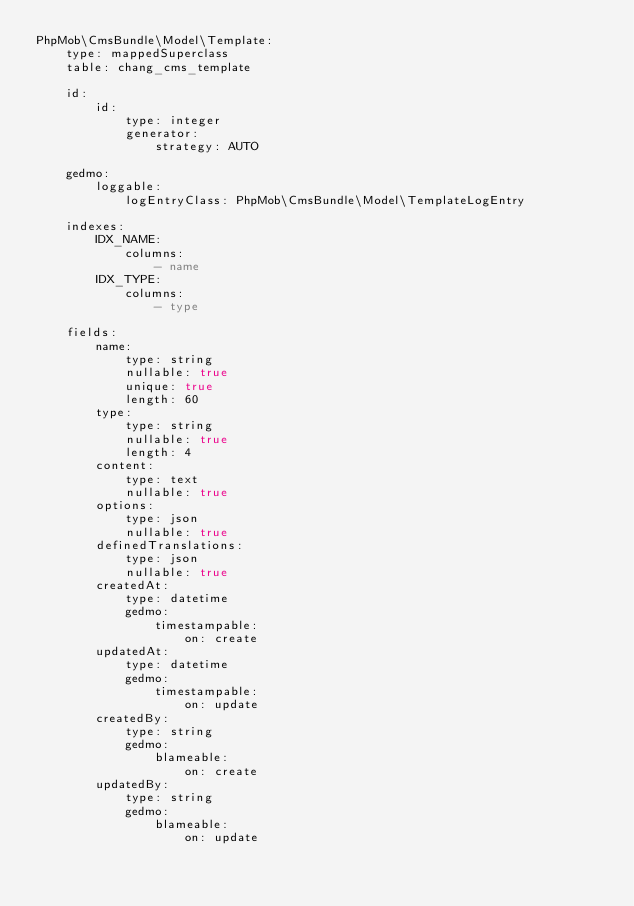<code> <loc_0><loc_0><loc_500><loc_500><_YAML_>PhpMob\CmsBundle\Model\Template:
    type: mappedSuperclass
    table: chang_cms_template

    id:
        id:
            type: integer
            generator:
                strategy: AUTO

    gedmo:
        loggable:
            logEntryClass: PhpMob\CmsBundle\Model\TemplateLogEntry

    indexes:
        IDX_NAME:
            columns:
                - name
        IDX_TYPE:
            columns:
                - type

    fields:
        name:
            type: string
            nullable: true
            unique: true
            length: 60
        type:
            type: string
            nullable: true
            length: 4
        content:
            type: text
            nullable: true
        options:
            type: json
            nullable: true
        definedTranslations:
            type: json
            nullable: true
        createdAt:
            type: datetime
            gedmo:
                timestampable:
                    on: create
        updatedAt:
            type: datetime
            gedmo:
                timestampable:
                    on: update
        createdBy:
            type: string
            gedmo:
                blameable:
                    on: create
        updatedBy:
            type: string
            gedmo:
                blameable:
                    on: update
</code> 